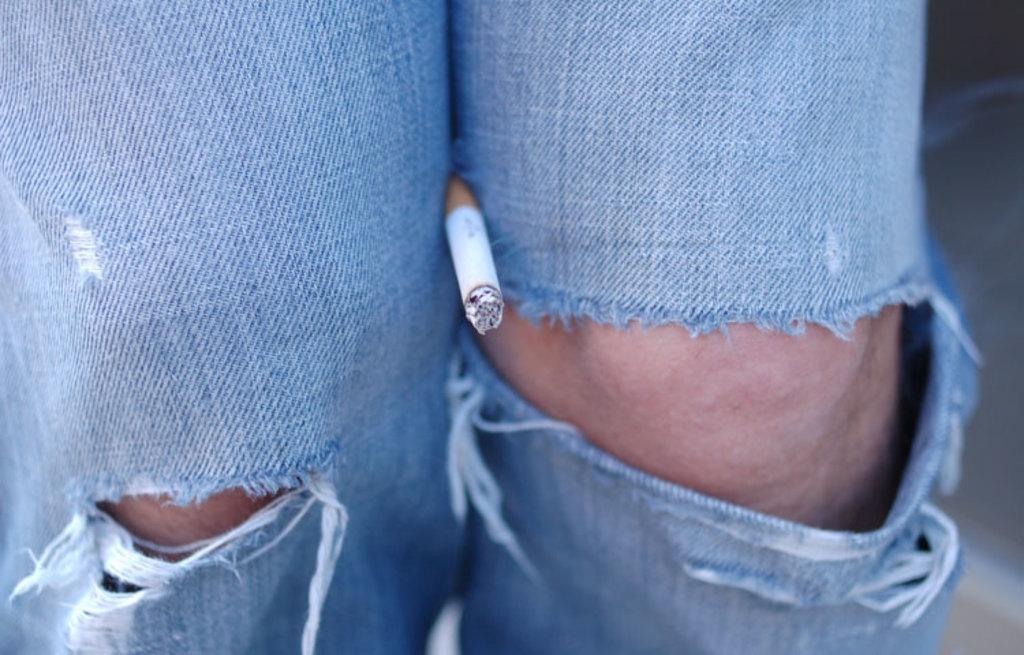What object is present in the image that is related to smoking? There is a cigarette in the image. Where is the cigarette placed in relation to a person? The cigarette is placed in between the knee of a person. How deep is the hole that the cigarette is placed in the image? There is no hole present in the image; the cigarette is placed in between the knee of a person. What type of light source is visible in the image? There is no light source visible in the image; it only features a cigarette and a person's knee. 